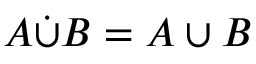<formula> <loc_0><loc_0><loc_500><loc_500>A { \dot { \cup } } B = A \cup B</formula> 